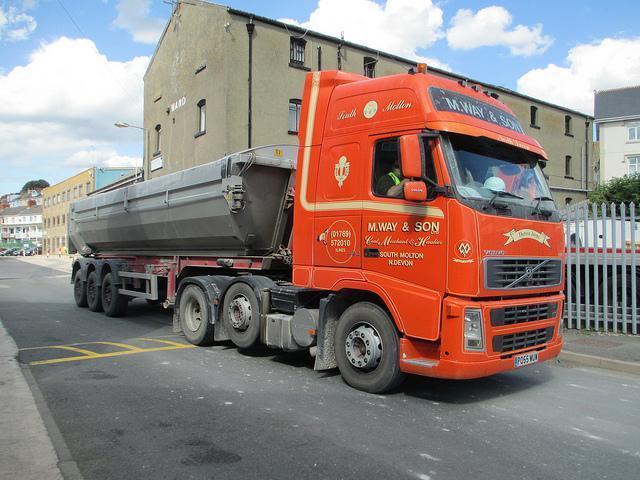How many reflections of a cat are visible?
Give a very brief answer. 0. 